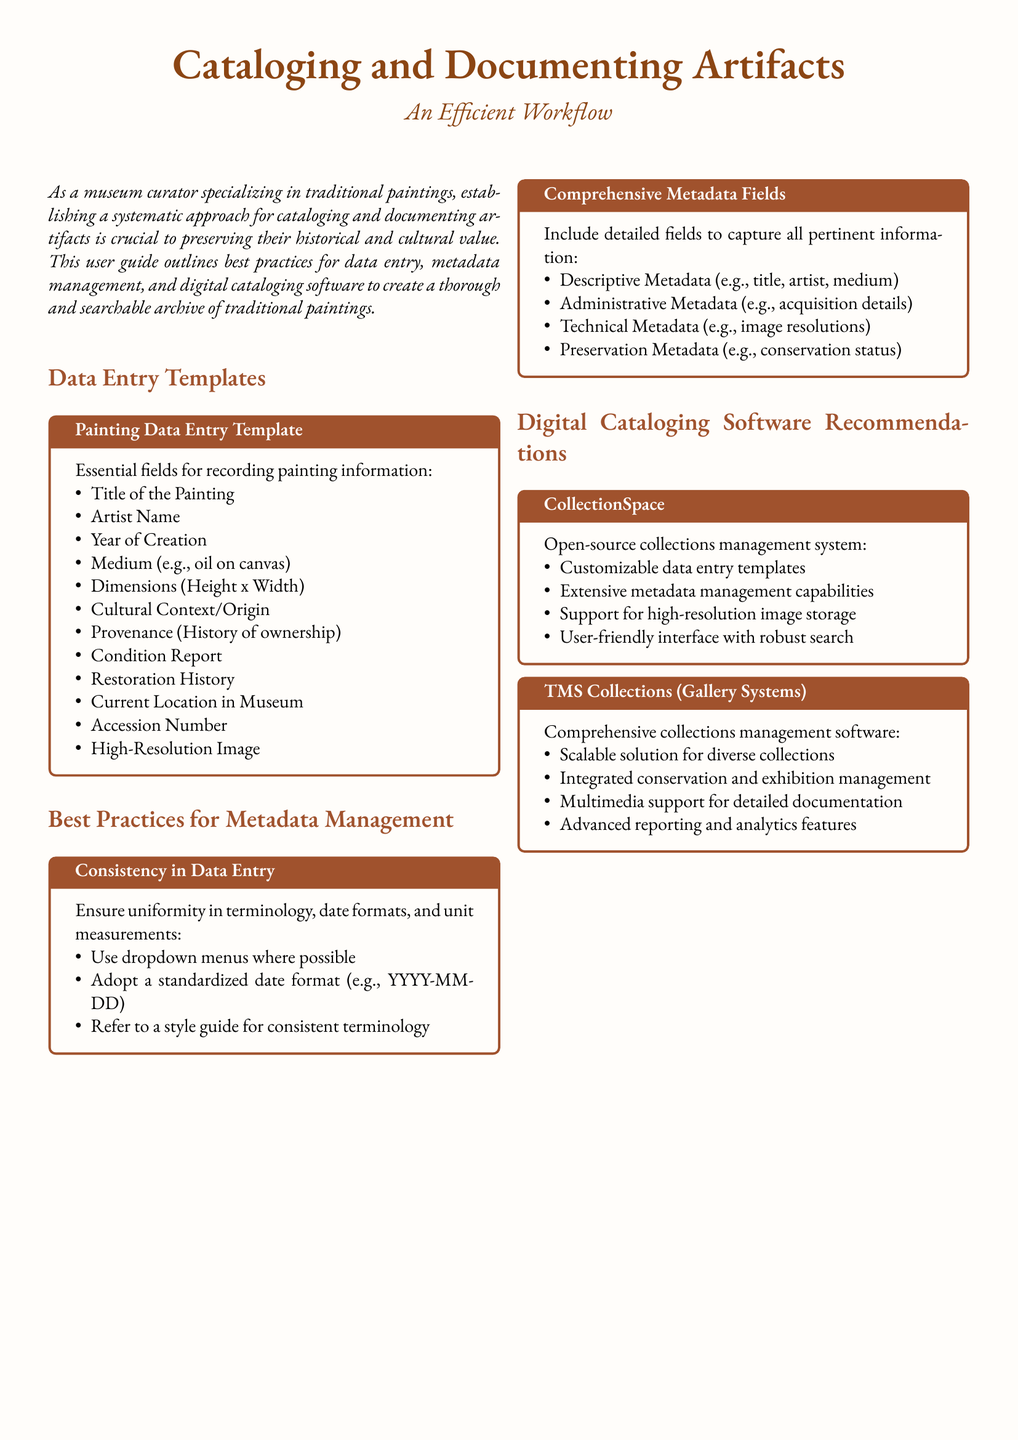What is the main purpose of the user guide? The user guide outlines best practices for data entry, metadata management, and digital cataloging software to create a thorough and searchable archive of traditional paintings.
Answer: Best practices for data entry, metadata management, and digital cataloging software Which software is recommended for open-source collections management? The guide specifies CollectionSpace as an open-source collections management system that offers customizable data entry templates and extensive metadata management capabilities.
Answer: CollectionSpace What field captures the history of ownership? The provenance field is included for recording the history of ownership of the painting.
Answer: Provenance What standardized date format is suggested? The guide recommends adopting a standardized date format of YYYY-MM-DD for consistency in data entry.
Answer: YYYY-MM-DD How many essential fields are suggested for painting information? There are twelve essential fields listed for recording painting information in the template provided.
Answer: Twelve What type of metadata is included for conservation status? Preservation Metadata is specifically designated for capturing conservation status information.
Answer: Preservation Metadata What type of interface does CollectionSpace have? CollectionSpace is described as having a user-friendly interface with robust search capabilities.
Answer: User-friendly interface with robust search What aspect of the paintings does the guide emphasize for documenting? The guide emphasizes capturing the cultural context/origin of the paintings as an important aspect of documentation.
Answer: Cultural Context/Origin What practices are recommended for consistency in data entry? The guide suggests using dropdown menus, adopting a standardized date format, and referring to a style guide for consistent terminology.
Answer: Use dropdown menus, standardized date format, style guide What does TMS Collections provide for collections management? TMS Collections offers an integrated solution for conservation and exhibition management, with multimedia support for documentation.
Answer: Integrated conservation and exhibition management 